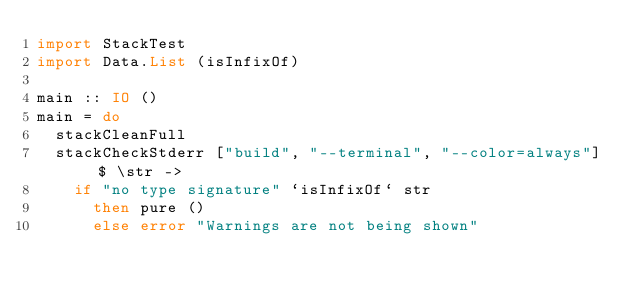<code> <loc_0><loc_0><loc_500><loc_500><_Haskell_>import StackTest
import Data.List (isInfixOf)

main :: IO ()
main = do
  stackCleanFull
  stackCheckStderr ["build", "--terminal", "--color=always"] $ \str ->
    if "no type signature" `isInfixOf` str
      then pure ()
      else error "Warnings are not being shown"
</code> 